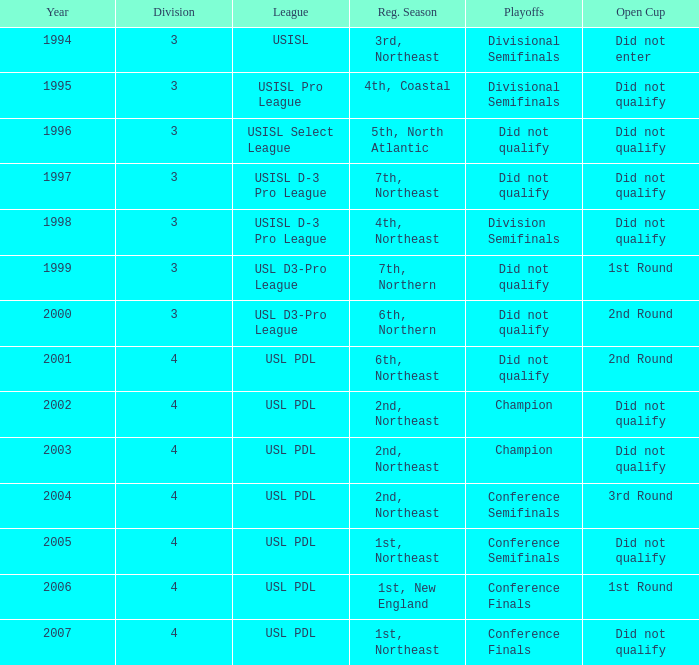Mame the reg season for 2001 6th, Northeast. 